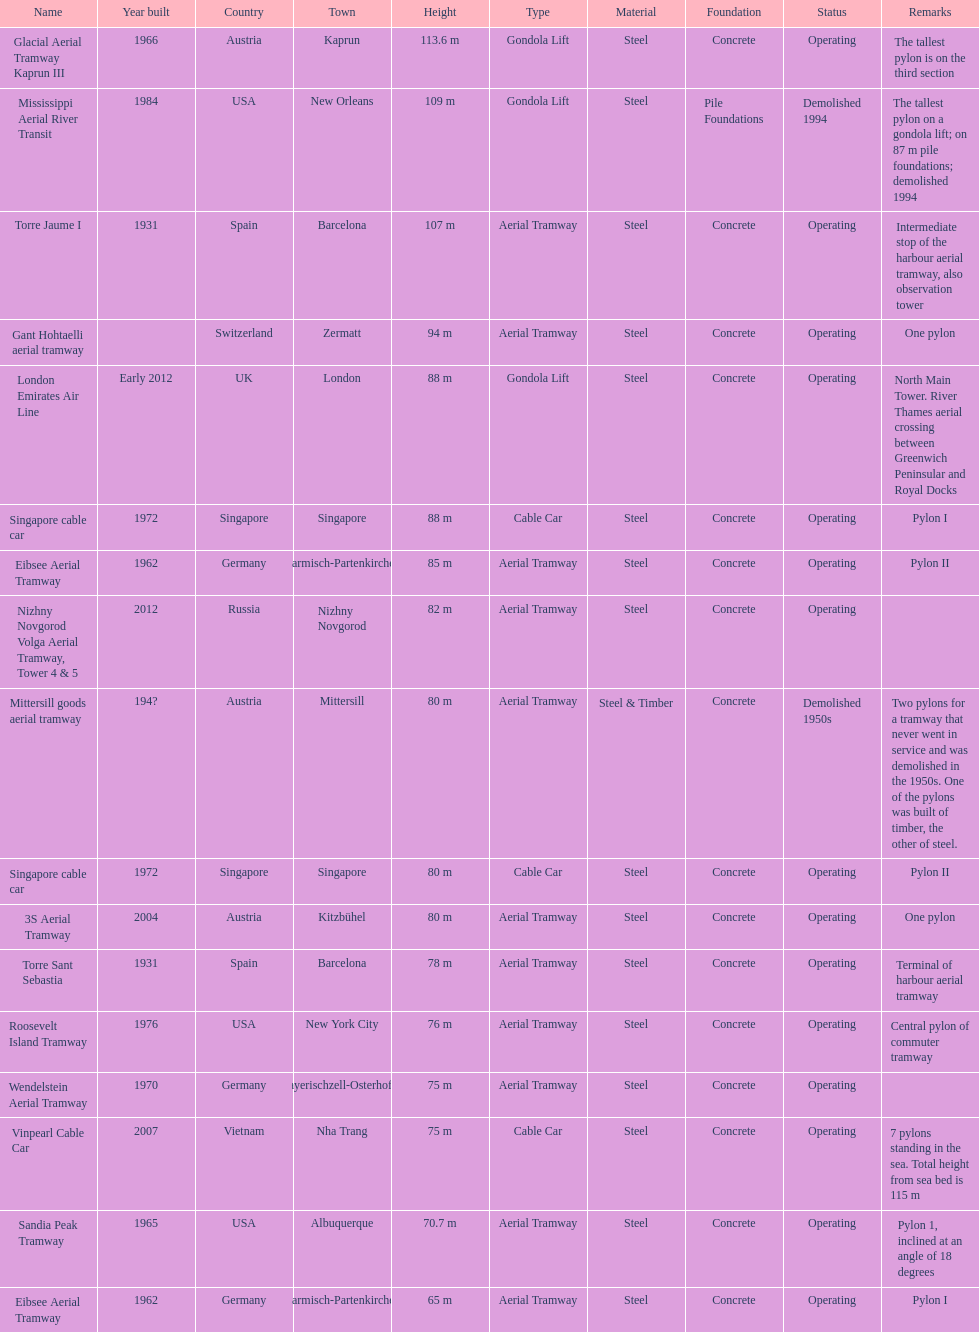The london emirates air line pylon has the same height as which pylon? Singapore cable car. 